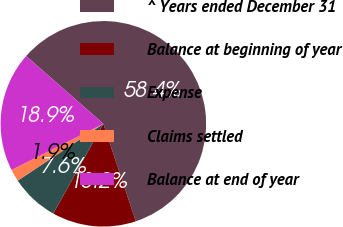<chart> <loc_0><loc_0><loc_500><loc_500><pie_chart><fcel>^ Years ended December 31<fcel>Balance at beginning of year<fcel>Expense<fcel>Claims settled<fcel>Balance at end of year<nl><fcel>58.43%<fcel>13.22%<fcel>7.57%<fcel>1.92%<fcel>18.87%<nl></chart> 